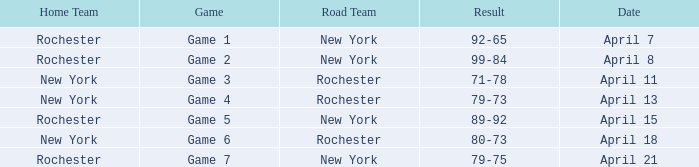Which Date has a Game of game 3? April 11. 